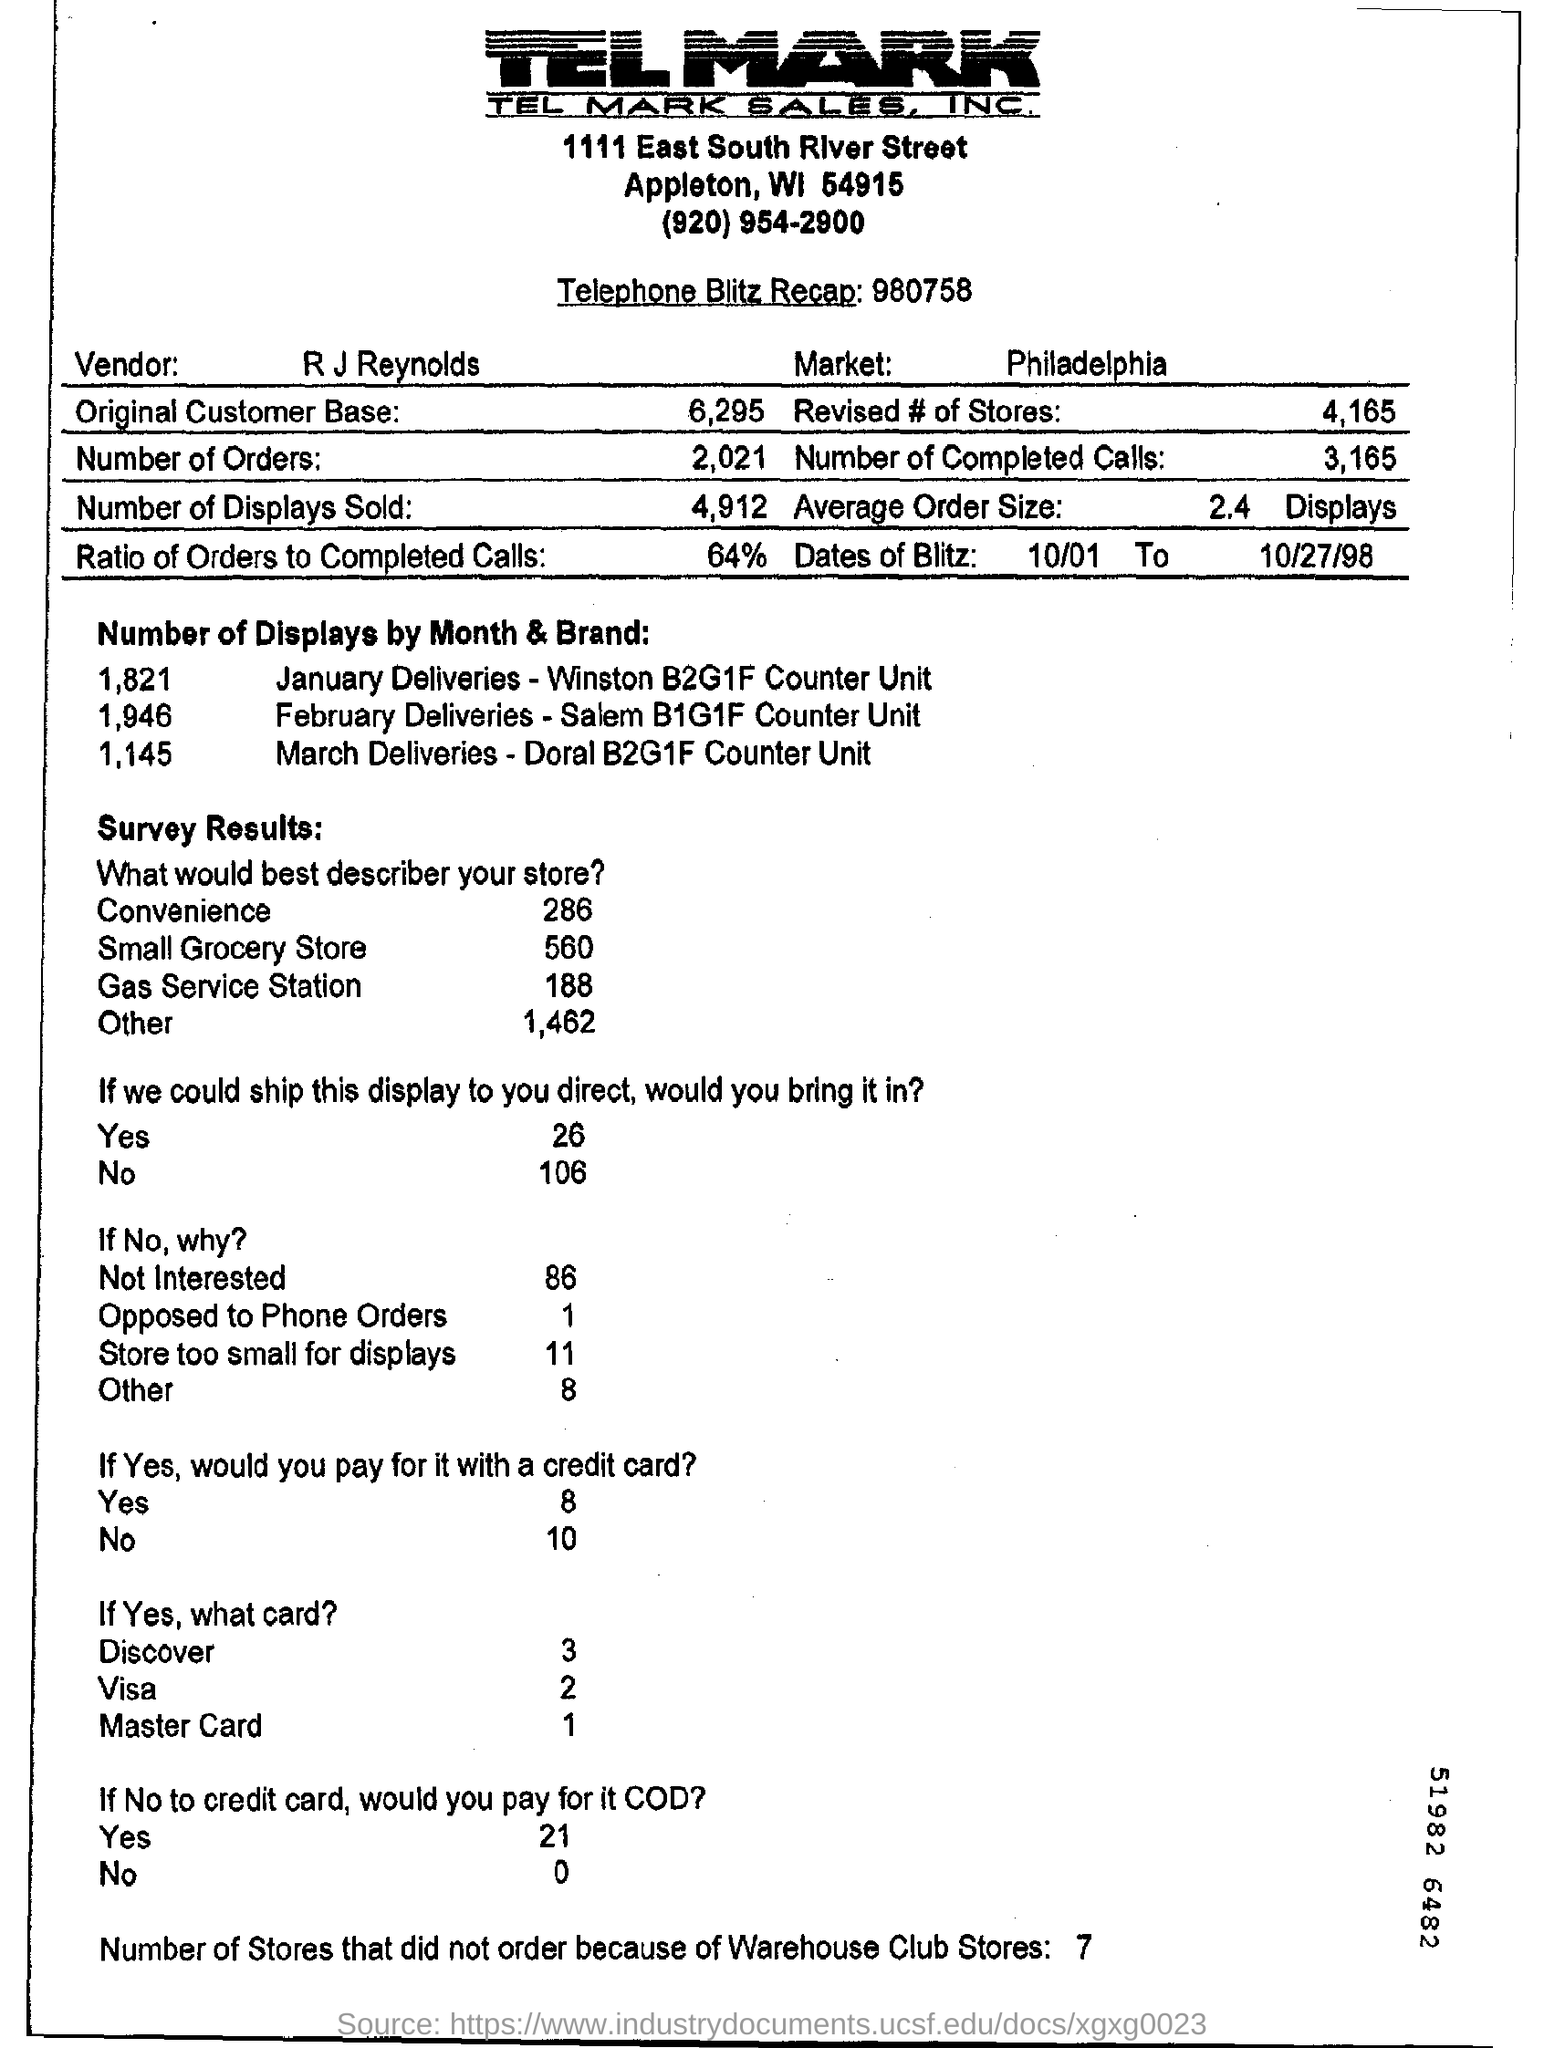Indicate a few pertinent items in this graphic. The completion rate of cells is 64%. The vendor's name is R J Reynolds. In the month of March, there were a total of 1,145 deliveries. The name of the market is Philadelphia. Seven stores did not place an order because of Warehouse club stores. 